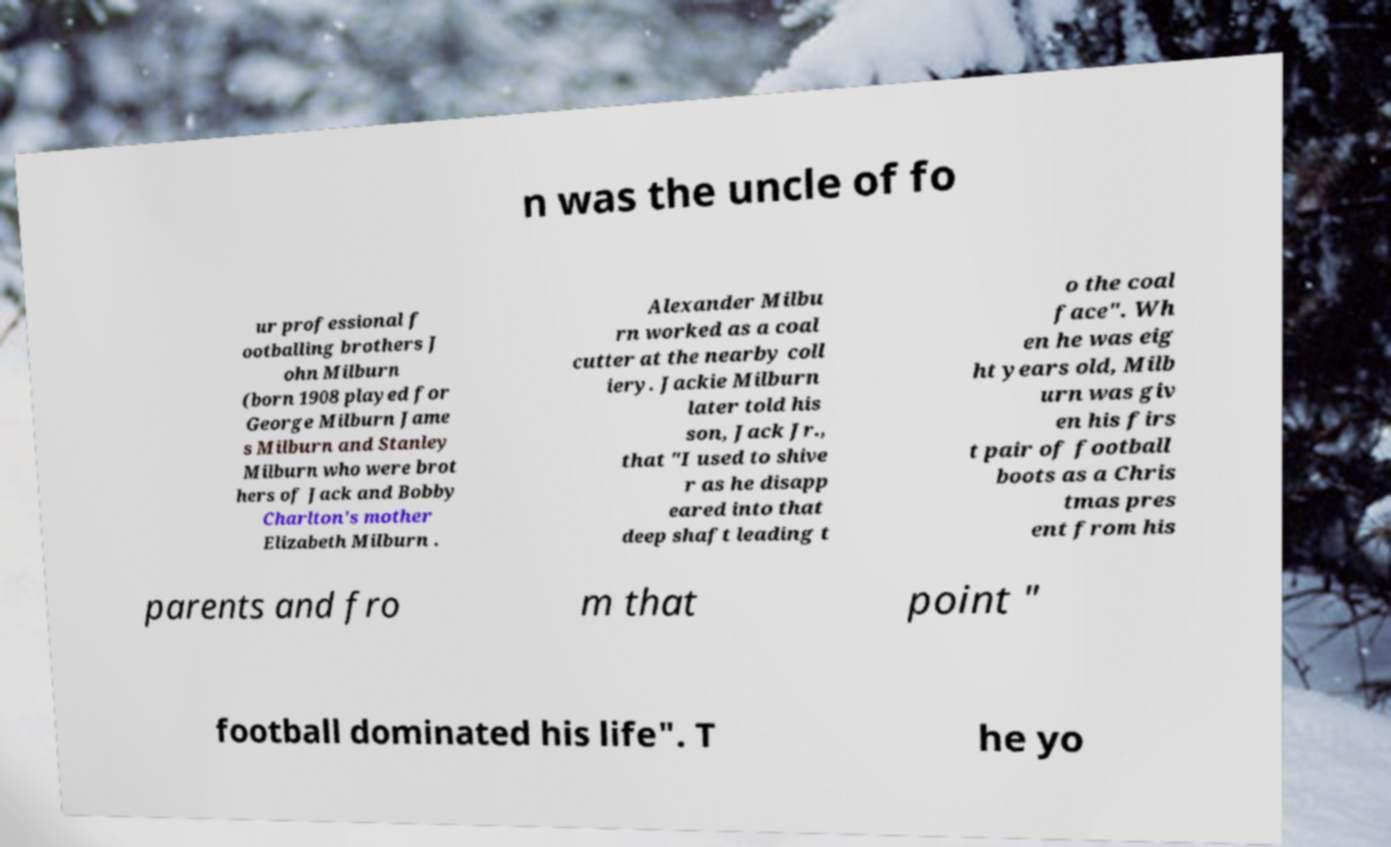Can you read and provide the text displayed in the image?This photo seems to have some interesting text. Can you extract and type it out for me? n was the uncle of fo ur professional f ootballing brothers J ohn Milburn (born 1908 played for George Milburn Jame s Milburn and Stanley Milburn who were brot hers of Jack and Bobby Charlton's mother Elizabeth Milburn . Alexander Milbu rn worked as a coal cutter at the nearby coll iery. Jackie Milburn later told his son, Jack Jr., that "I used to shive r as he disapp eared into that deep shaft leading t o the coal face". Wh en he was eig ht years old, Milb urn was giv en his firs t pair of football boots as a Chris tmas pres ent from his parents and fro m that point " football dominated his life". T he yo 